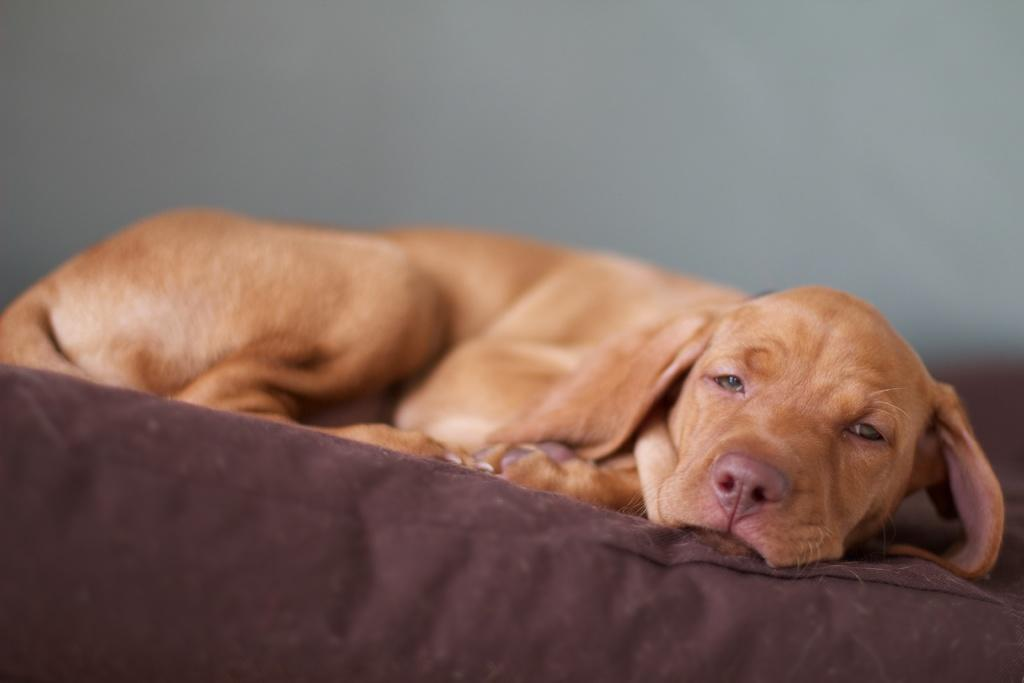What animal can be seen in the picture? There is a dog in the picture. What is the dog doing in the picture? The dog is sleeping. What is the dog resting on in the picture? The dog is on a blanket. What type of cabbage is the dog using as a pillow in the picture? There is no cabbage present in the picture; the dog is resting on a blanket. What invention is the dog holding in its paws in the picture? There is no invention present in the picture; the dog is sleeping. 